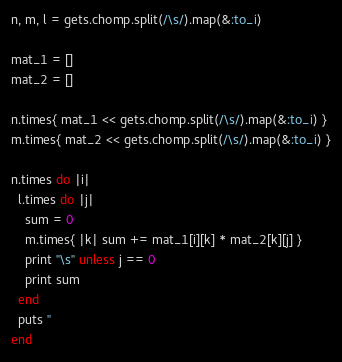Convert code to text. <code><loc_0><loc_0><loc_500><loc_500><_Ruby_>n, m, l = gets.chomp.split(/\s/).map(&:to_i)

mat_1 = []
mat_2 = []

n.times{ mat_1 << gets.chomp.split(/\s/).map(&:to_i) }
m.times{ mat_2 << gets.chomp.split(/\s/).map(&:to_i) }

n.times do |i|
  l.times do |j|
    sum = 0
    m.times{ |k| sum += mat_1[i][k] * mat_2[k][j] }
    print "\s" unless j == 0
    print sum
  end
  puts ''
end</code> 